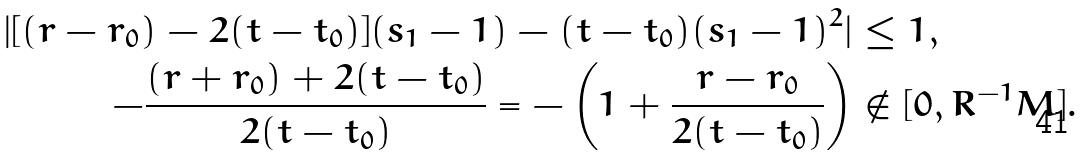Convert formula to latex. <formula><loc_0><loc_0><loc_500><loc_500>| [ ( r - r _ { 0 } ) - 2 ( t - t _ { 0 } ) ] ( s _ { 1 } - 1 ) - ( t - t _ { 0 } ) ( s _ { 1 } - 1 ) ^ { 2 } | & \leq 1 , \\ - \frac { ( r + r _ { 0 } ) + 2 ( t - t _ { 0 } ) } { 2 ( t - t _ { 0 } ) } = - \left ( 1 + \frac { r - r _ { 0 } } { 2 ( t - t _ { 0 } ) } \right ) & \notin [ 0 , R ^ { - 1 } M ] .</formula> 